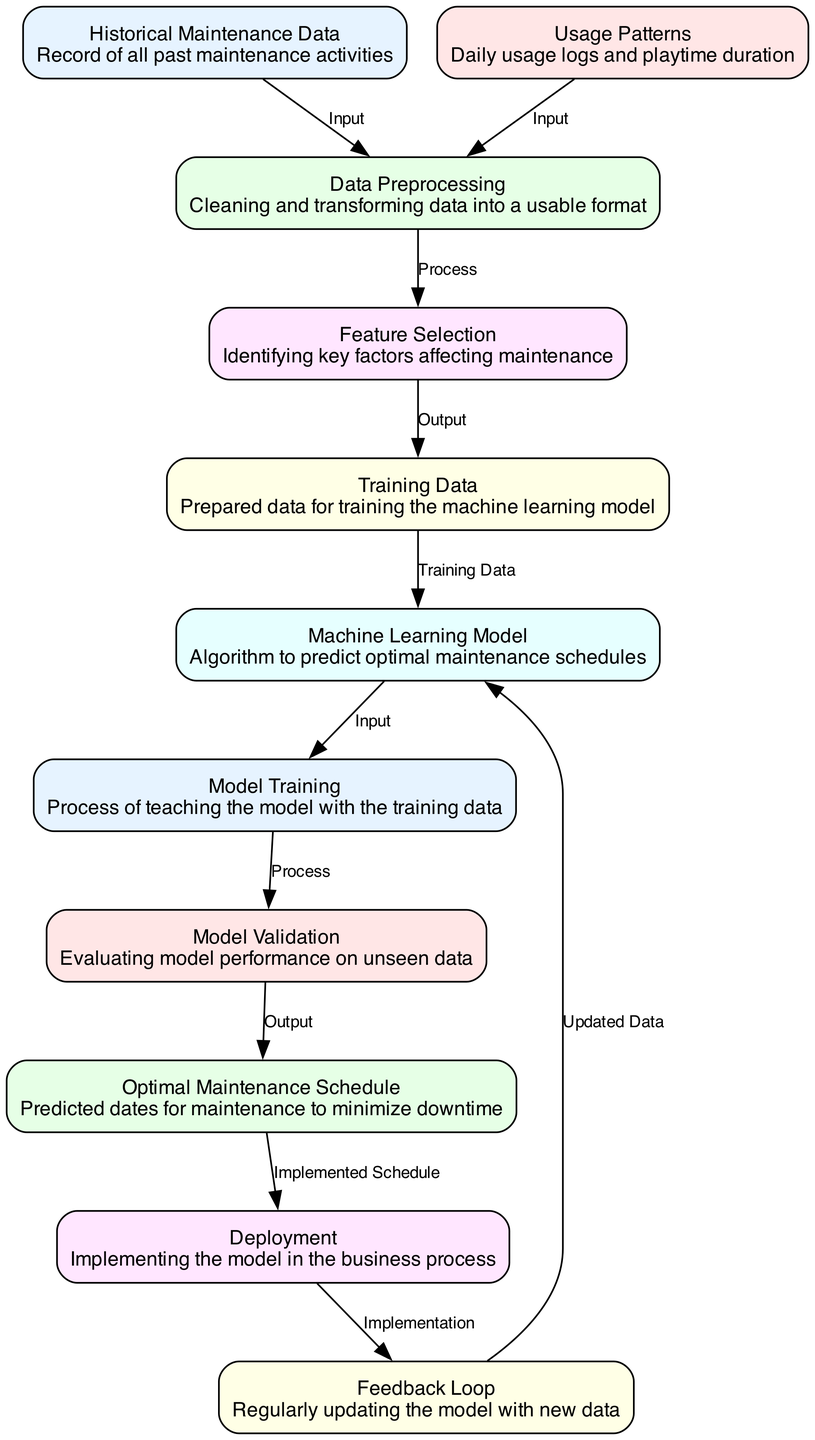What are the two inputs into data preprocessing? The two inputs into the data preprocessing node are Historical Maintenance Data and Usage Patterns, as indicated by the edges leading into this node.
Answer: Historical Maintenance Data, Usage Patterns How many nodes are in the diagram? The diagram contains 11 nodes, which are all the distinct operations and data sources depicted in the structure.
Answer: 11 What is the output of model validation? The output of the model validation node is the Optimal Maintenance Schedule, representing the predicted maintenance dates after evaluating the model's performance.
Answer: Optimal Maintenance Schedule Which node processes training data? The node that processes the training data is Model Training, as it directly takes input from the training data node and carries out the training process.
Answer: Model Training What are the two outputs resulting from feature selection? The output of feature selection is the prepared training data, which is later utilized by the machine learning model, but there are no other direct outputs shown.
Answer: Training Data What does the feedback loop do? The feedback loop is responsible for regularly updating the machine learning model with new data, ensuring the model remains accurate over time.
Answer: Updated Data Where does the deployment node receive its input from? The deployment node receives its input from the Optimal Maintenance Schedule, which provides the implementation details derived from the model validation step.
Answer: Optimal Maintenance Schedule Which process follows model validation? The process that follows model validation is the creation of the Optimal Maintenance Schedule, where the validated model predictions are finalized.
Answer: Optimal Maintenance Schedule What is the relationship between the historical maintenance data and data preprocessing? The relationship is that the historical maintenance data serves as an input to the data preprocessing node, which cleans and transforms it for further use.
Answer: Input 